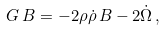<formula> <loc_0><loc_0><loc_500><loc_500>G \, B = - 2 \rho \dot { \rho } \, B - 2 \dot { \Omega } \, ,</formula> 